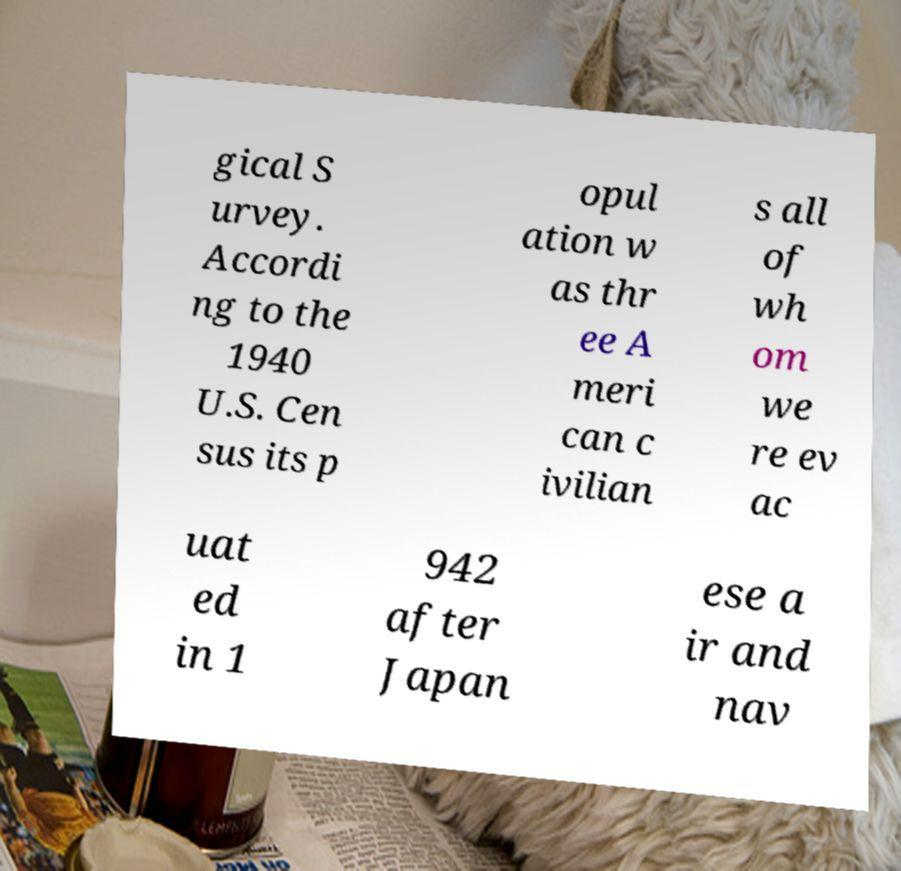Could you assist in decoding the text presented in this image and type it out clearly? gical S urvey. Accordi ng to the 1940 U.S. Cen sus its p opul ation w as thr ee A meri can c ivilian s all of wh om we re ev ac uat ed in 1 942 after Japan ese a ir and nav 